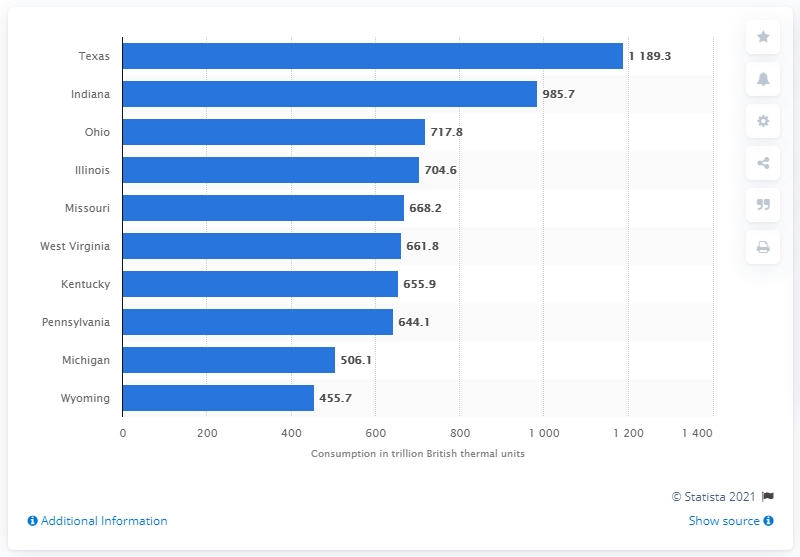Give some essential details in this illustration. In 2018, the state of Ohio consumed 717.8 billion British thermal units of energy, which represents the amount of energy required to heat one pound of water by one degree Fahrenheit. 